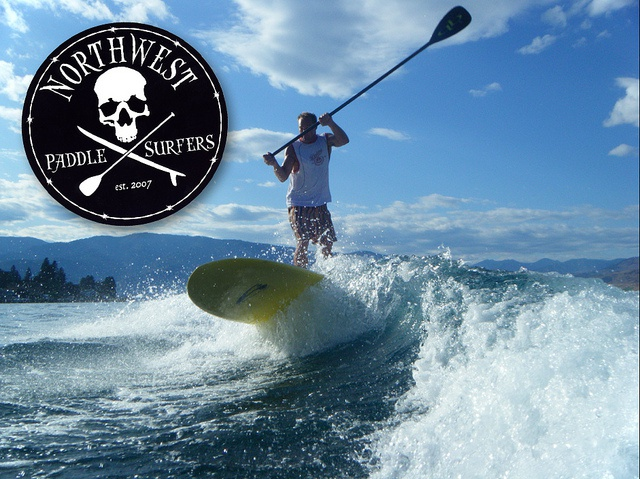Describe the objects in this image and their specific colors. I can see people in lightblue, navy, gray, and black tones and surfboard in lightblue, black, and darkgreen tones in this image. 